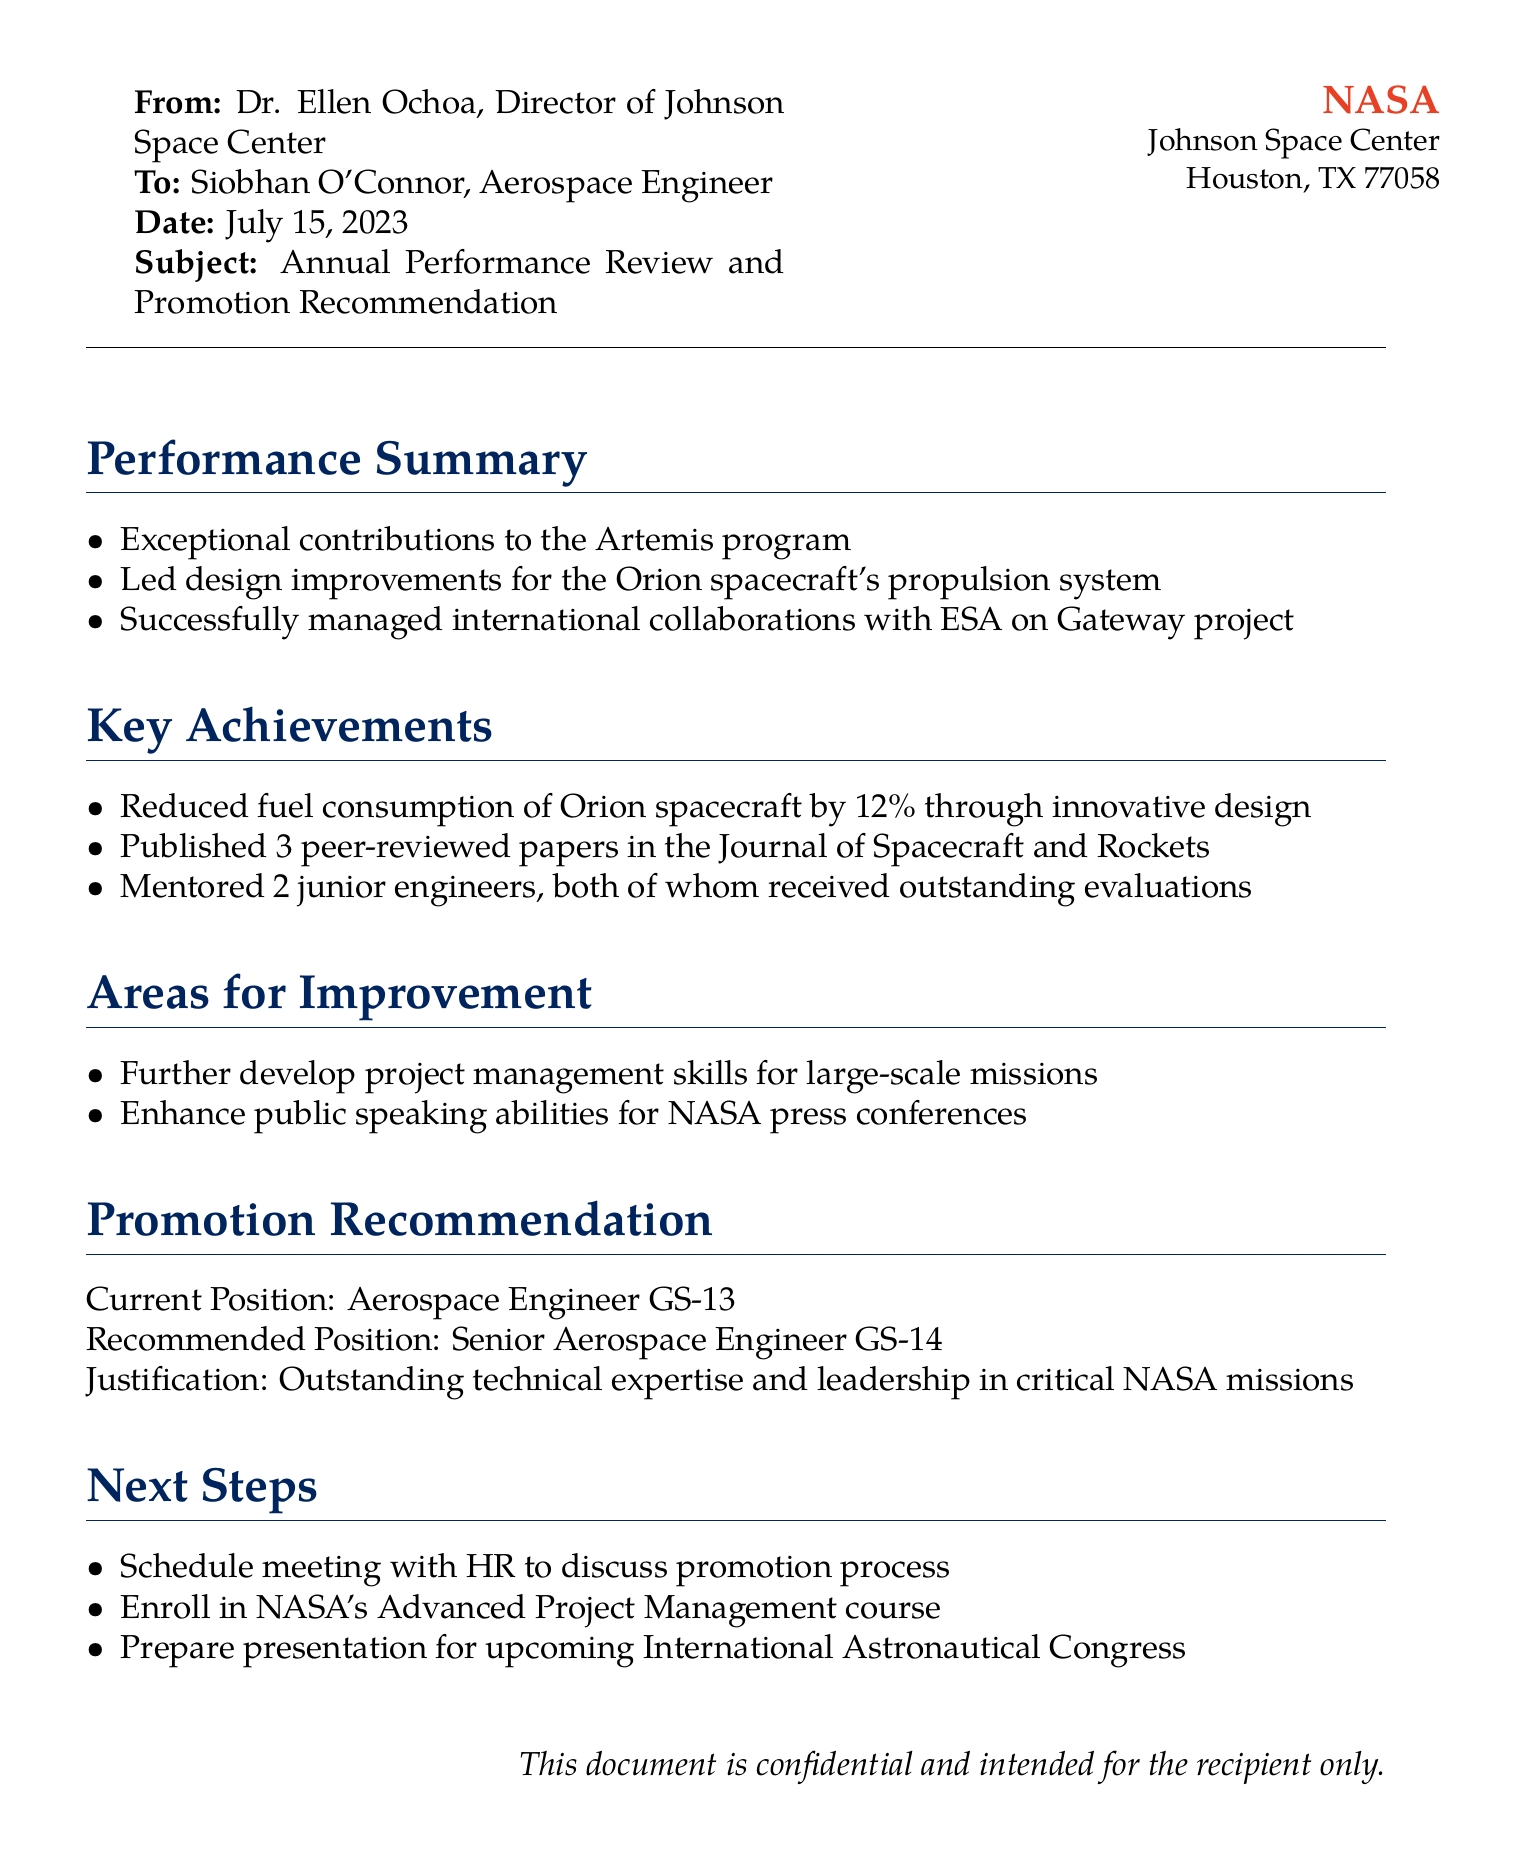what is the name of the director of Johnson Space Center? The name of the director is mentioned at the beginning of the document, Dr. Ellen Ochoa.
Answer: Dr. Ellen Ochoa what is Siobhan O'Connor's current position? The current position of Siobhan O'Connor is specified in the promotion recommendation section of the document.
Answer: Aerospace Engineer GS-13 what is the date of the performance review document? The date is provided in the header of the document.
Answer: July 15, 2023 how many peer-reviewed papers did Siobhan publish? The number of peer-reviewed papers is listed under the key achievements section.
Answer: 3 what is the recommended position for Siobhan O'Connor? The recommended position is described in the promotion recommendation section of the document.
Answer: Senior Aerospace Engineer GS-14 what is one area for improvement noted in the document? The areas for improvement are listed in the respective section, and one is chosen for the answer.
Answer: Project management skills what percentage of fuel consumption was reduced? The document specifies the reduction in fuel consumption under key achievements.
Answer: 12% what course should Siobhan enroll in next? The next step mentioned suggests a specific course to help with professional development.
Answer: Advanced Project Management course what is the justification for the promotion recommendation? The rationale for the promotion is provided in the promotion recommendation section.
Answer: Outstanding technical expertise and leadership in critical NASA missions 